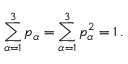Convert formula to latex. <formula><loc_0><loc_0><loc_500><loc_500>\sum _ { \alpha = 1 } ^ { 3 } p _ { \alpha } = \sum _ { \alpha = 1 } ^ { 3 } p _ { \alpha } ^ { 2 } = 1 \, .</formula> 